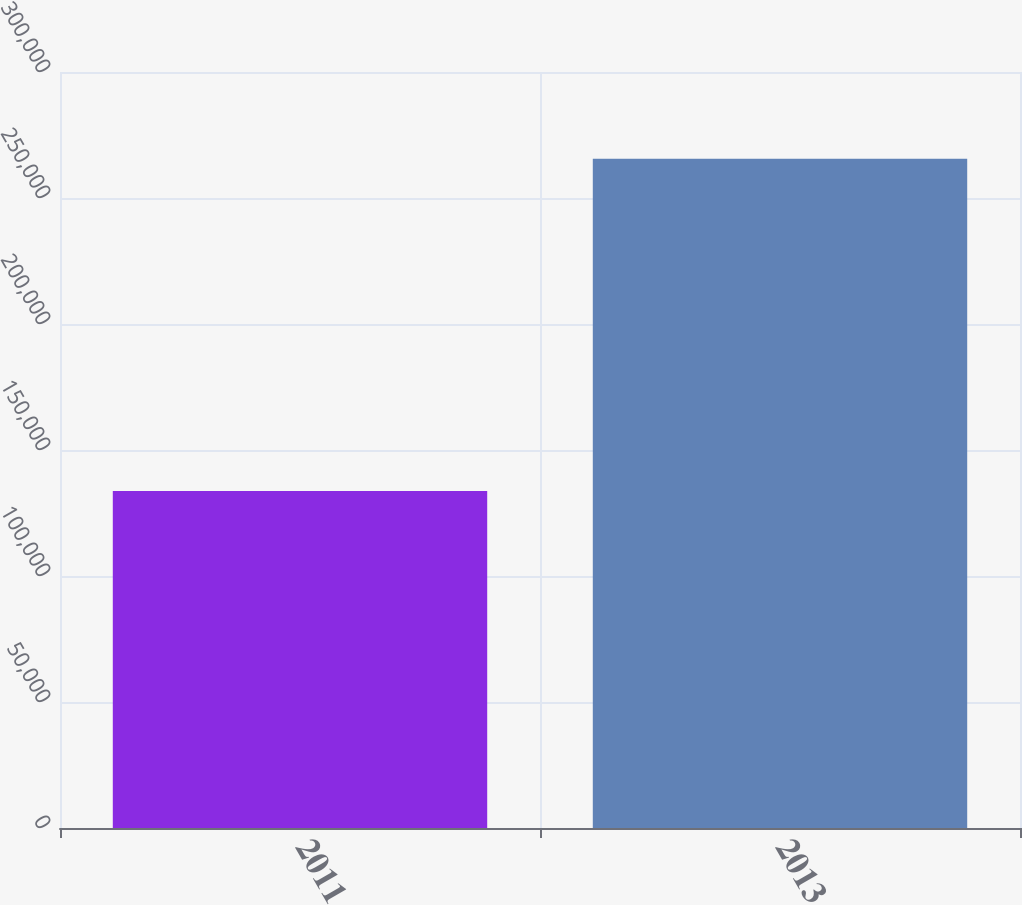<chart> <loc_0><loc_0><loc_500><loc_500><bar_chart><fcel>2011<fcel>2013<nl><fcel>133775<fcel>265583<nl></chart> 